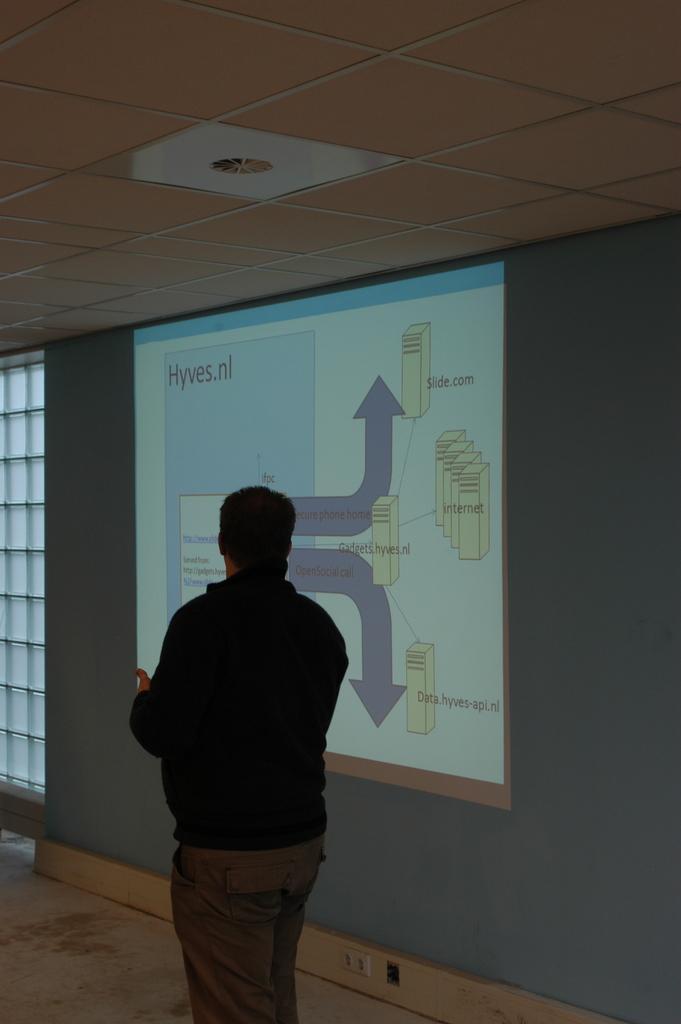Can you describe this image briefly? In this image I can see a person wearing black jacket is standing and in the background I can see the window, the projection on the wall and the ceiling. 